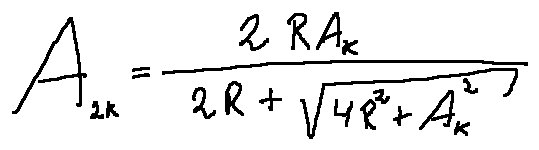<formula> <loc_0><loc_0><loc_500><loc_500>A _ { 2 k } = \frac { 2 R A _ { k } } { 2 R + \sqrt { 4 R ^ { 2 } + A _ { k } ^ { 2 } } }</formula> 